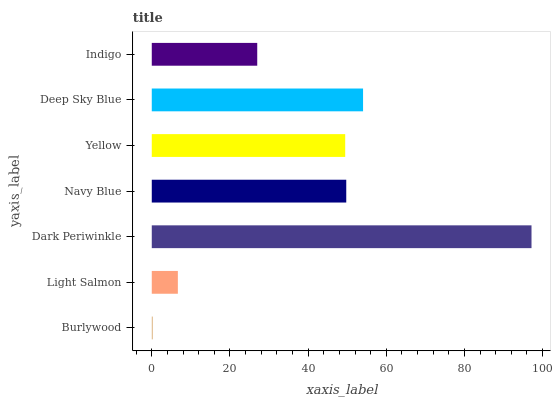Is Burlywood the minimum?
Answer yes or no. Yes. Is Dark Periwinkle the maximum?
Answer yes or no. Yes. Is Light Salmon the minimum?
Answer yes or no. No. Is Light Salmon the maximum?
Answer yes or no. No. Is Light Salmon greater than Burlywood?
Answer yes or no. Yes. Is Burlywood less than Light Salmon?
Answer yes or no. Yes. Is Burlywood greater than Light Salmon?
Answer yes or no. No. Is Light Salmon less than Burlywood?
Answer yes or no. No. Is Yellow the high median?
Answer yes or no. Yes. Is Yellow the low median?
Answer yes or no. Yes. Is Dark Periwinkle the high median?
Answer yes or no. No. Is Deep Sky Blue the low median?
Answer yes or no. No. 